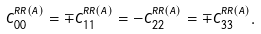Convert formula to latex. <formula><loc_0><loc_0><loc_500><loc_500>C _ { 0 0 } ^ { R R ( A ) } = \mp C _ { 1 1 } ^ { R R ( A ) } = - C _ { 2 2 } ^ { R R ( A ) } = \mp C _ { 3 3 } ^ { R R ( A ) } .</formula> 